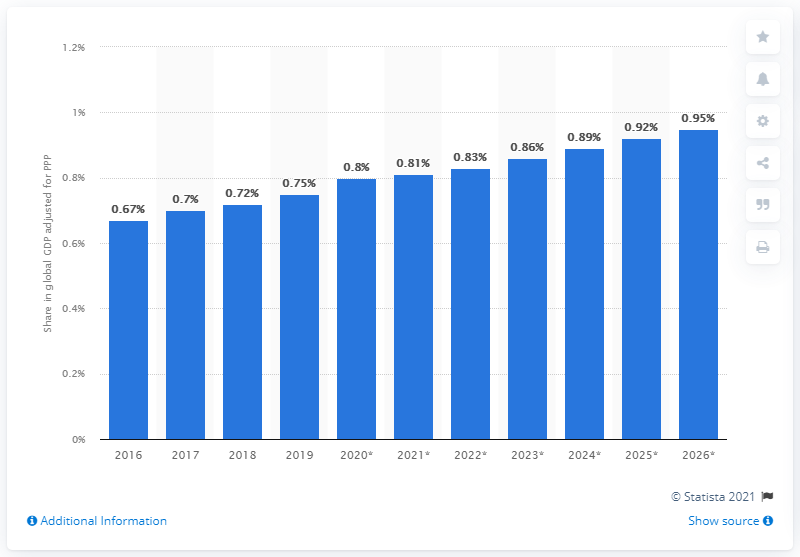Mention a couple of crucial points in this snapshot. According to the Global Gross Domestic Product (GDP) adjusted for Purchasing Power Parity (PPP) in 2019, Vietnam's share was estimated to be 0.75%. 